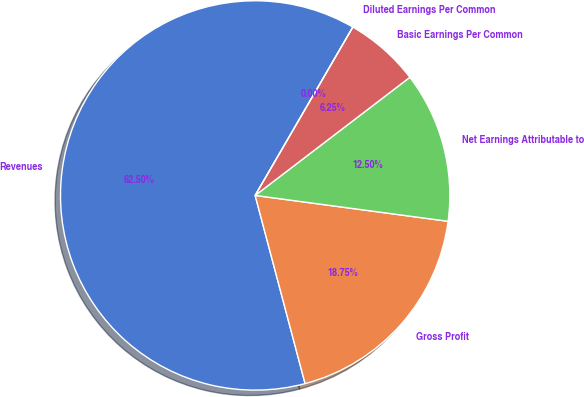Convert chart. <chart><loc_0><loc_0><loc_500><loc_500><pie_chart><fcel>Revenues<fcel>Gross Profit<fcel>Net Earnings Attributable to<fcel>Basic Earnings Per Common<fcel>Diluted Earnings Per Common<nl><fcel>62.49%<fcel>18.75%<fcel>12.5%<fcel>6.25%<fcel>0.0%<nl></chart> 